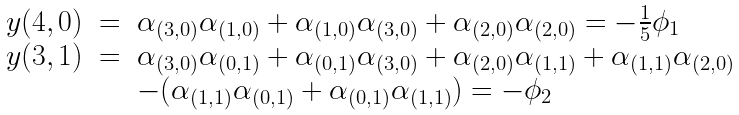Convert formula to latex. <formula><loc_0><loc_0><loc_500><loc_500>\begin{array} { r c l } y ( 4 , 0 ) & = & \alpha _ { ( 3 , 0 ) } \alpha _ { ( 1 , 0 ) } + \alpha _ { ( 1 , 0 ) } \alpha _ { ( 3 , 0 ) } + \alpha _ { ( 2 , 0 ) } \alpha _ { ( 2 , 0 ) } = - \frac { 1 } { 5 } \phi _ { 1 } \\ y ( 3 , 1 ) & = & \alpha _ { ( 3 , 0 ) } \alpha _ { ( 0 , 1 ) } + \alpha _ { ( 0 , 1 ) } \alpha _ { ( 3 , 0 ) } + \alpha _ { ( 2 , 0 ) } \alpha _ { ( 1 , 1 ) } + \alpha _ { ( 1 , 1 ) } \alpha _ { ( 2 , 0 ) } \\ & & - ( \alpha _ { ( 1 , 1 ) } \alpha _ { ( 0 , 1 ) } + \alpha _ { ( 0 , 1 ) } \alpha _ { ( 1 , 1 ) } ) = - \phi _ { 2 } \end{array}</formula> 